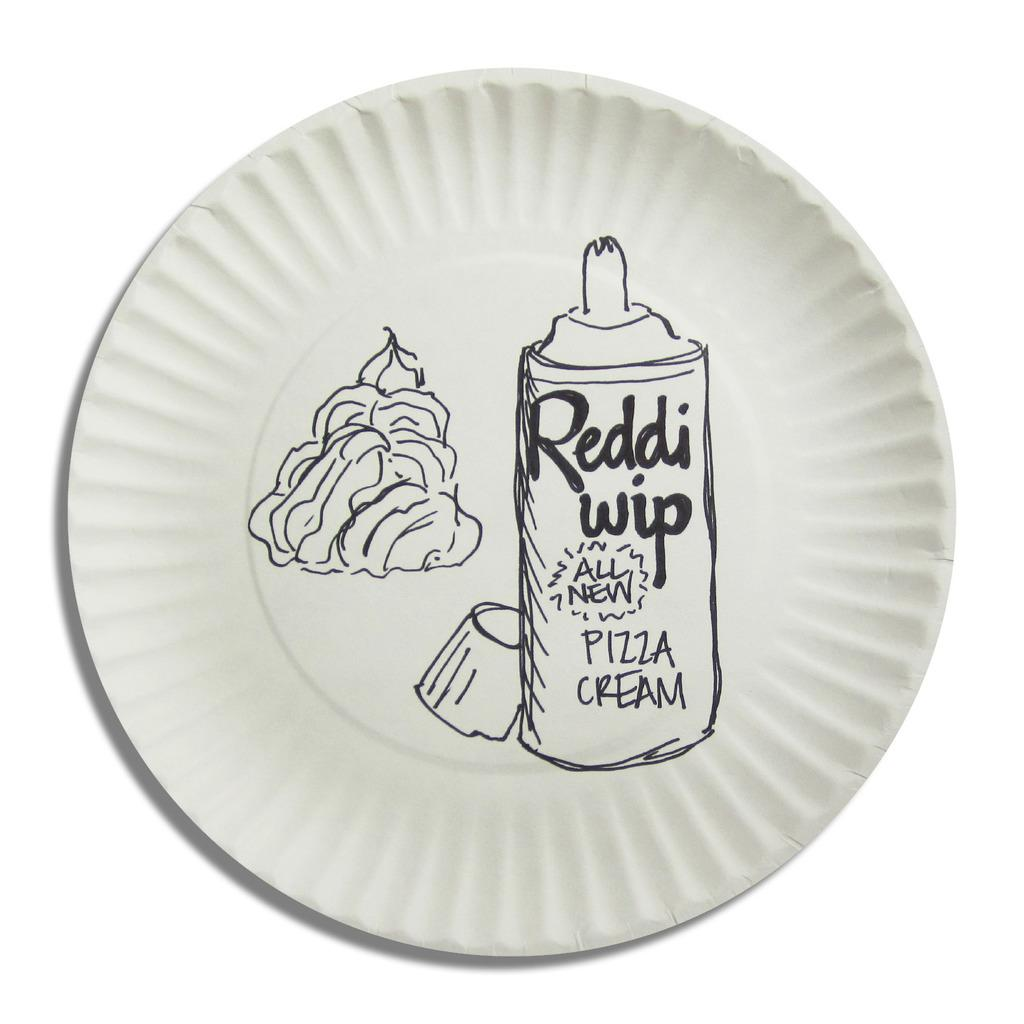What is depicted on the plate in the image? There is a sketch on a plate in the image. What color is the background of the image? The background of the image is white in color. How many rabbits can be seen breathing in the image? There are no rabbits present in the image, and therefore no such activity can be observed. 